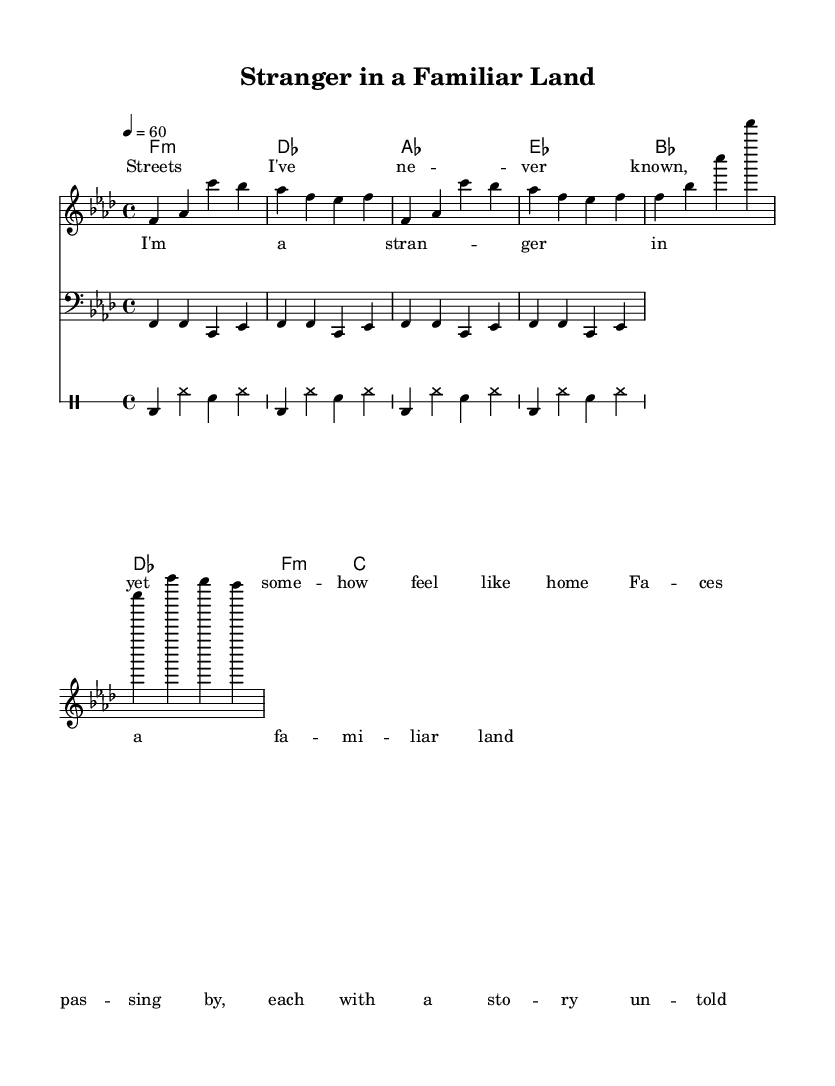What is the key signature of this music? The key signature indicates that the piece is in F minor, which consists of four flats: B♭, E♭, A♭, and D♭. This can be identified from the initial indication before the time signature in the music sheet.
Answer: F minor What is the time signature of the piece? The time signature displayed on the sheet music is 4/4, which means there are four beats in a measure and the quarter note receives one beat. This information is usually represented at the beginning of the score.
Answer: 4/4 What is the tempo setting for this piece? The tempo marking shows that the piece is to be played at a tempo of 60 beats per minute. This is indicated at the beginning of the score next to the 'tempo' directive.
Answer: 60 How many measures are repeated in the melody section? The melody section indicates a repeat of 2 measures twice, shown by the "repeat unfold 2" notation. This means the specified measures are played two times before moving on.
Answer: 2 What is the primary theme explored in the lyrics of the song? The lyrics express themes of identity and belonging, particularly focusing on the experience of feeling like a stranger while simultaneously finding a sense of familiarity in a new place. This can be gleaned from the content of the lyrics provided under the 'verse' and 'chorus' sections of the music.
Answer: Identity and belonging What is the role of the bass line in this piece? The bass line provides a harmonic foundation by establishing the root notes of the chords played in the progression. It plays F, C, and E♭ in a repeated pattern, which complements and supports the melody and the chords indicated in the score.
Answer: Harmonic foundation How does the drum pattern contribute to the style of Rhythm and Blues in this piece? The drum pattern consists of a repetitive kick drum and snare rhythm that emphasizes the groove typical of Rhythm and Blues. This includes the combination of kick drum on the downbeats with hi-hats and snares, creating a laid-back yet rhythmic feel that supports the emotional delivery of slow jams.
Answer: Emphasizes groove 